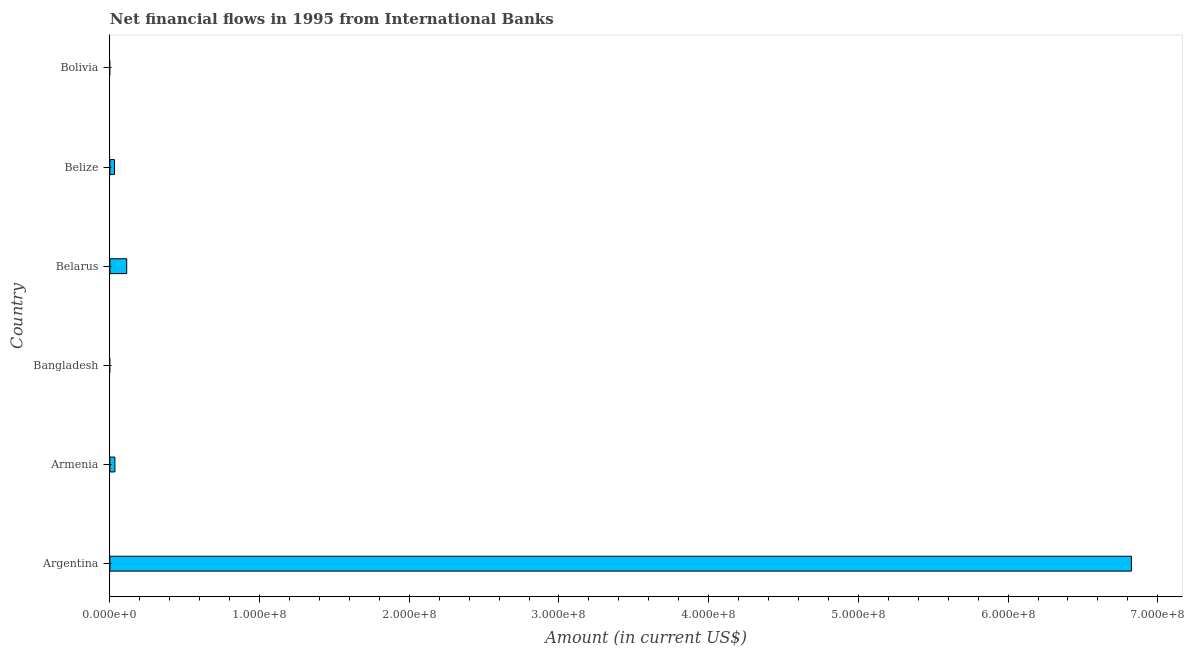Does the graph contain any zero values?
Ensure brevity in your answer.  Yes. What is the title of the graph?
Offer a very short reply. Net financial flows in 1995 from International Banks. What is the label or title of the Y-axis?
Give a very brief answer. Country. What is the net financial flows from ibrd in Bangladesh?
Offer a very short reply. 0. Across all countries, what is the maximum net financial flows from ibrd?
Give a very brief answer. 6.82e+08. What is the sum of the net financial flows from ibrd?
Offer a terse response. 7.00e+08. What is the difference between the net financial flows from ibrd in Argentina and Belize?
Your response must be concise. 6.79e+08. What is the average net financial flows from ibrd per country?
Your response must be concise. 1.17e+08. What is the median net financial flows from ibrd?
Keep it short and to the point. 3.21e+06. What is the ratio of the net financial flows from ibrd in Armenia to that in Belarus?
Your answer should be very brief. 0.3. Is the net financial flows from ibrd in Armenia less than that in Belarus?
Your answer should be very brief. Yes. Is the difference between the net financial flows from ibrd in Argentina and Armenia greater than the difference between any two countries?
Offer a terse response. No. What is the difference between the highest and the second highest net financial flows from ibrd?
Keep it short and to the point. 6.71e+08. Is the sum of the net financial flows from ibrd in Armenia and Belarus greater than the maximum net financial flows from ibrd across all countries?
Make the answer very short. No. What is the difference between the highest and the lowest net financial flows from ibrd?
Keep it short and to the point. 6.82e+08. In how many countries, is the net financial flows from ibrd greater than the average net financial flows from ibrd taken over all countries?
Give a very brief answer. 1. Are all the bars in the graph horizontal?
Your answer should be very brief. Yes. What is the difference between two consecutive major ticks on the X-axis?
Your answer should be compact. 1.00e+08. Are the values on the major ticks of X-axis written in scientific E-notation?
Provide a succinct answer. Yes. What is the Amount (in current US$) of Argentina?
Give a very brief answer. 6.82e+08. What is the Amount (in current US$) of Armenia?
Give a very brief answer. 3.35e+06. What is the Amount (in current US$) in Belarus?
Offer a terse response. 1.12e+07. What is the Amount (in current US$) of Belize?
Provide a succinct answer. 3.07e+06. What is the Amount (in current US$) of Bolivia?
Your response must be concise. 0. What is the difference between the Amount (in current US$) in Argentina and Armenia?
Make the answer very short. 6.79e+08. What is the difference between the Amount (in current US$) in Argentina and Belarus?
Provide a short and direct response. 6.71e+08. What is the difference between the Amount (in current US$) in Argentina and Belize?
Offer a very short reply. 6.79e+08. What is the difference between the Amount (in current US$) in Armenia and Belarus?
Give a very brief answer. -7.88e+06. What is the difference between the Amount (in current US$) in Armenia and Belize?
Make the answer very short. 2.82e+05. What is the difference between the Amount (in current US$) in Belarus and Belize?
Offer a terse response. 8.16e+06. What is the ratio of the Amount (in current US$) in Argentina to that in Armenia?
Your answer should be compact. 203.64. What is the ratio of the Amount (in current US$) in Argentina to that in Belarus?
Your answer should be compact. 60.78. What is the ratio of the Amount (in current US$) in Argentina to that in Belize?
Your answer should be compact. 222.35. What is the ratio of the Amount (in current US$) in Armenia to that in Belarus?
Your answer should be compact. 0.3. What is the ratio of the Amount (in current US$) in Armenia to that in Belize?
Make the answer very short. 1.09. What is the ratio of the Amount (in current US$) in Belarus to that in Belize?
Offer a very short reply. 3.66. 